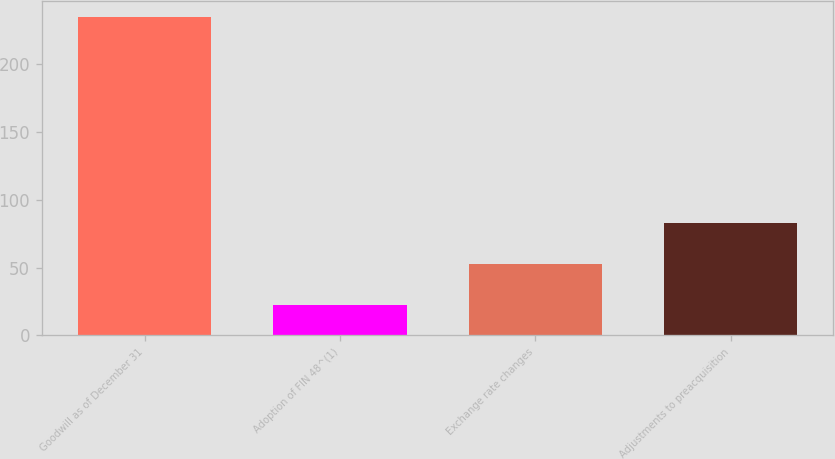Convert chart. <chart><loc_0><loc_0><loc_500><loc_500><bar_chart><fcel>Goodwill as of December 31<fcel>Adoption of FIN 48^(1)<fcel>Exchange rate changes<fcel>Adjustments to preacquisition<nl><fcel>235<fcel>22<fcel>52.5<fcel>83<nl></chart> 